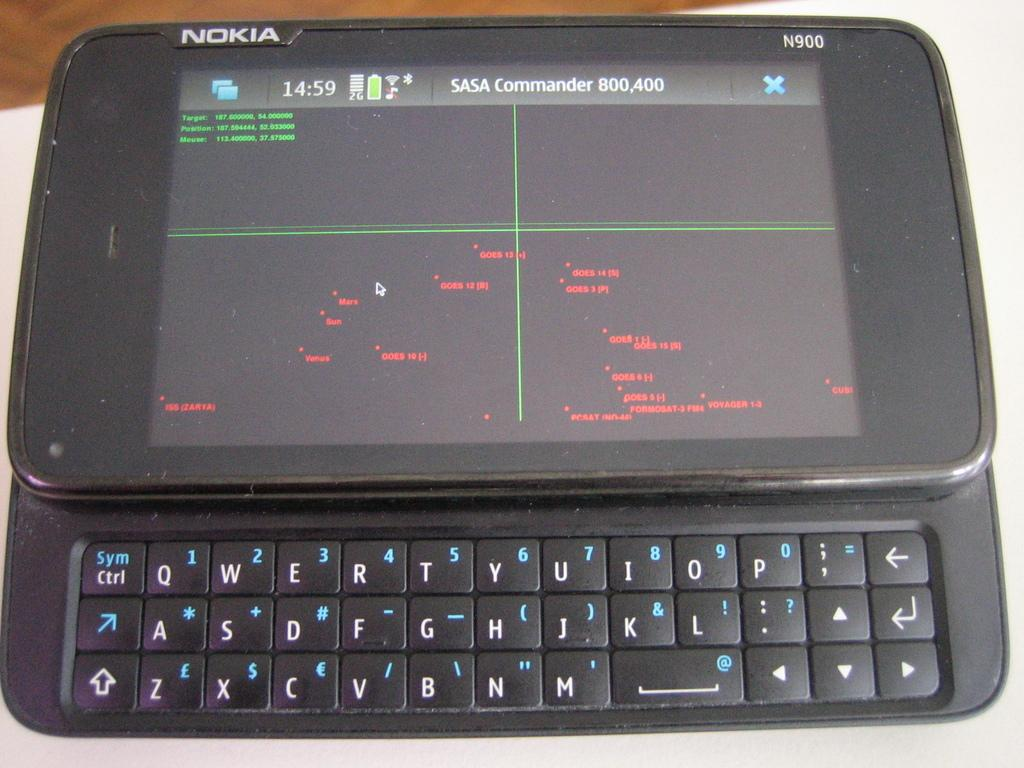<image>
Present a compact description of the photo's key features. An old Nokia phone with SASA Commander on the screen 